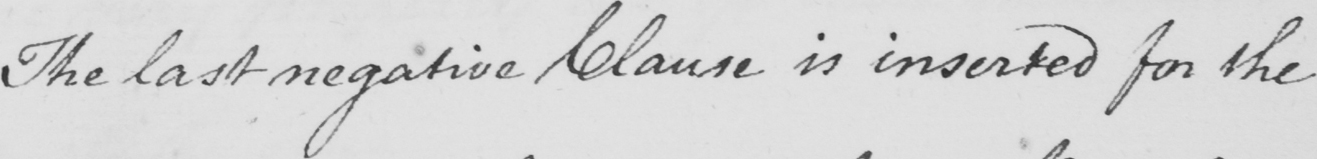Transcribe the text shown in this historical manuscript line. The last negative Clause is inserted for the 